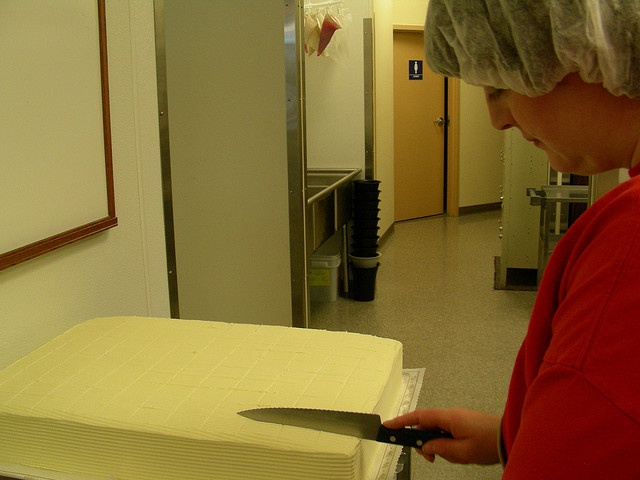Describe the objects in this image and their specific colors. I can see people in olive, maroon, and black tones, cake in olive and khaki tones, knife in olive, black, and tan tones, and sink in black and olive tones in this image. 